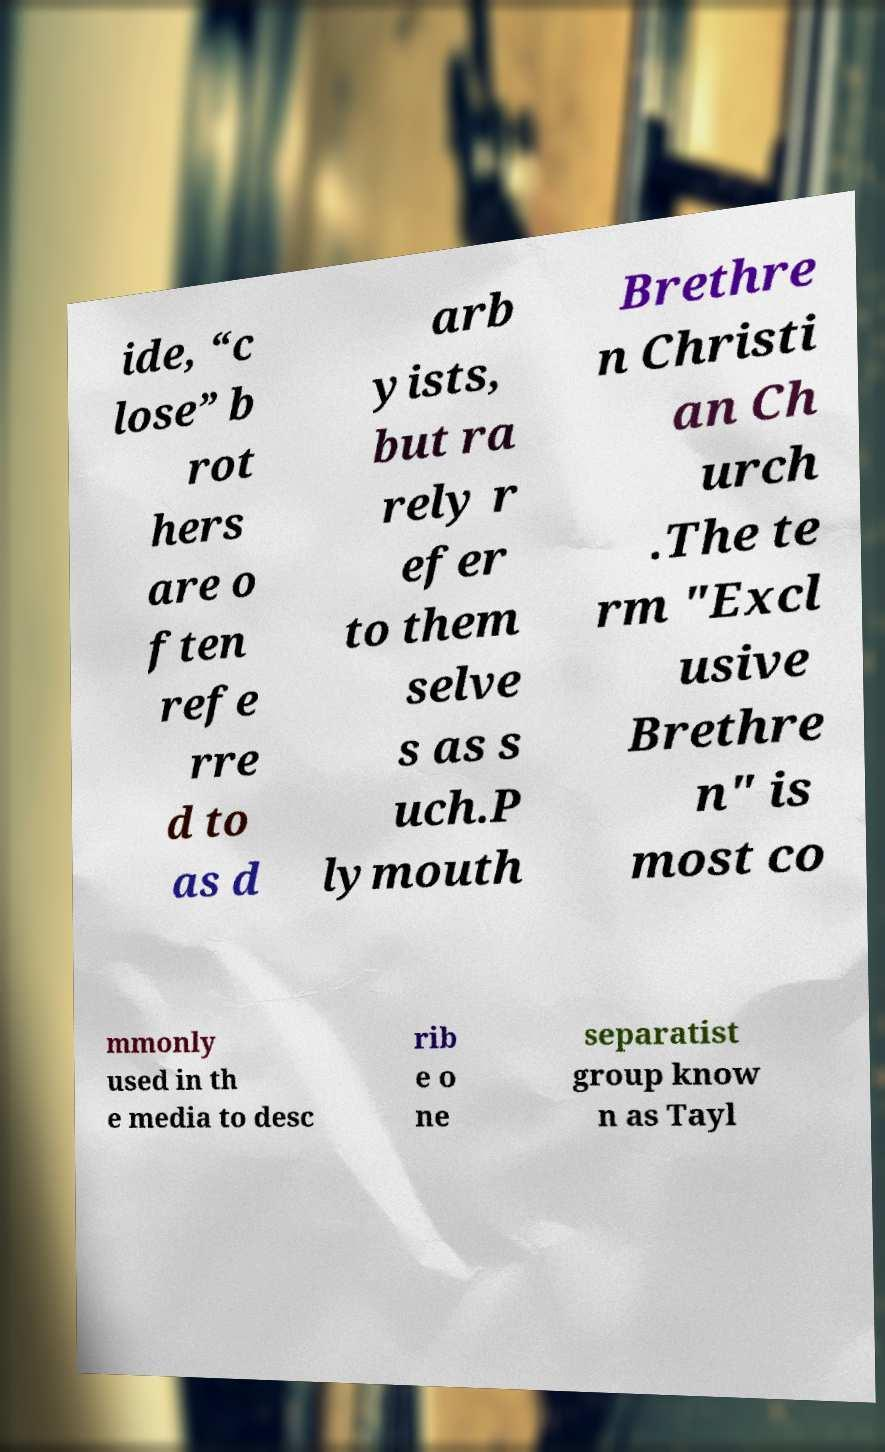Could you extract and type out the text from this image? ide, “c lose” b rot hers are o ften refe rre d to as d arb yists, but ra rely r efer to them selve s as s uch.P lymouth Brethre n Christi an Ch urch .The te rm "Excl usive Brethre n" is most co mmonly used in th e media to desc rib e o ne separatist group know n as Tayl 